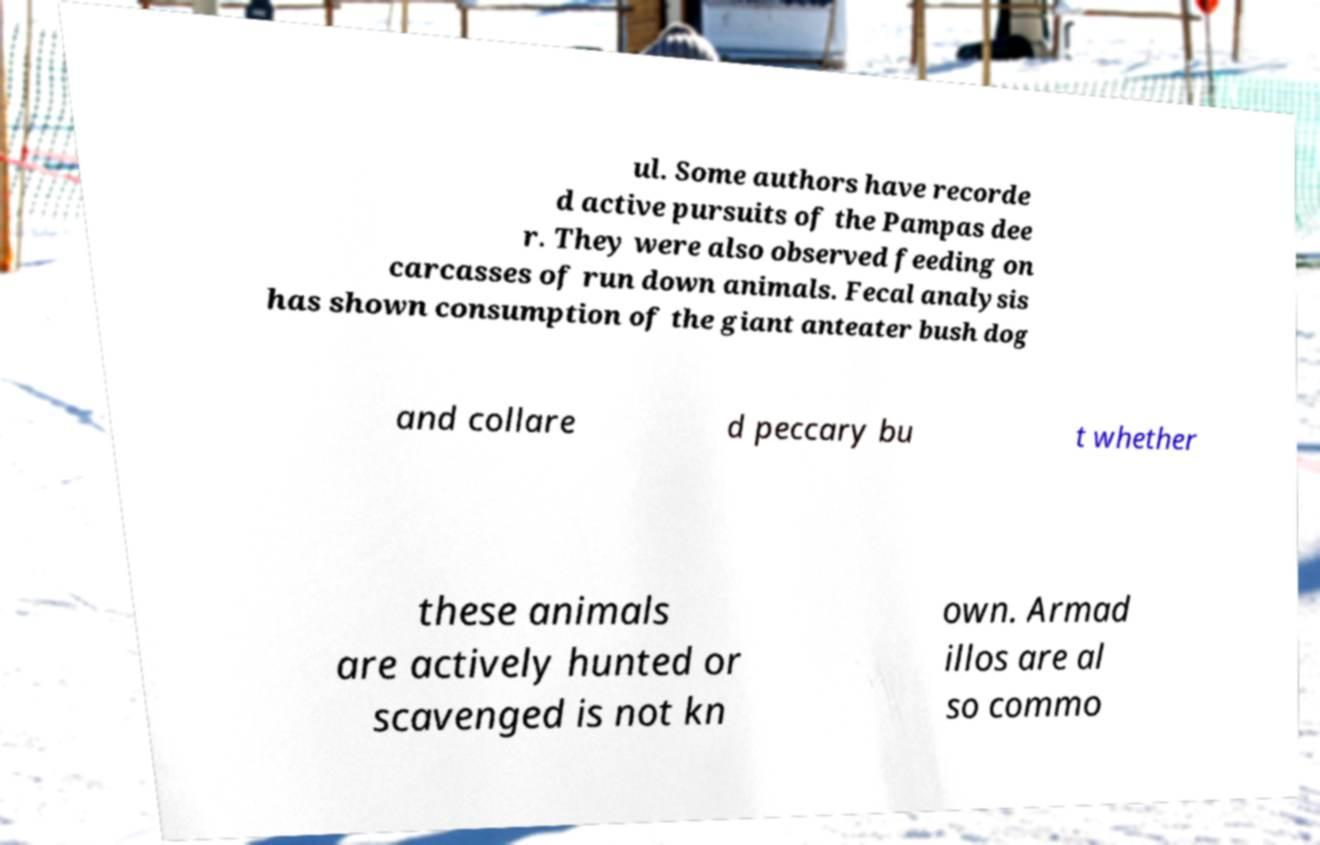I need the written content from this picture converted into text. Can you do that? ul. Some authors have recorde d active pursuits of the Pampas dee r. They were also observed feeding on carcasses of run down animals. Fecal analysis has shown consumption of the giant anteater bush dog and collare d peccary bu t whether these animals are actively hunted or scavenged is not kn own. Armad illos are al so commo 